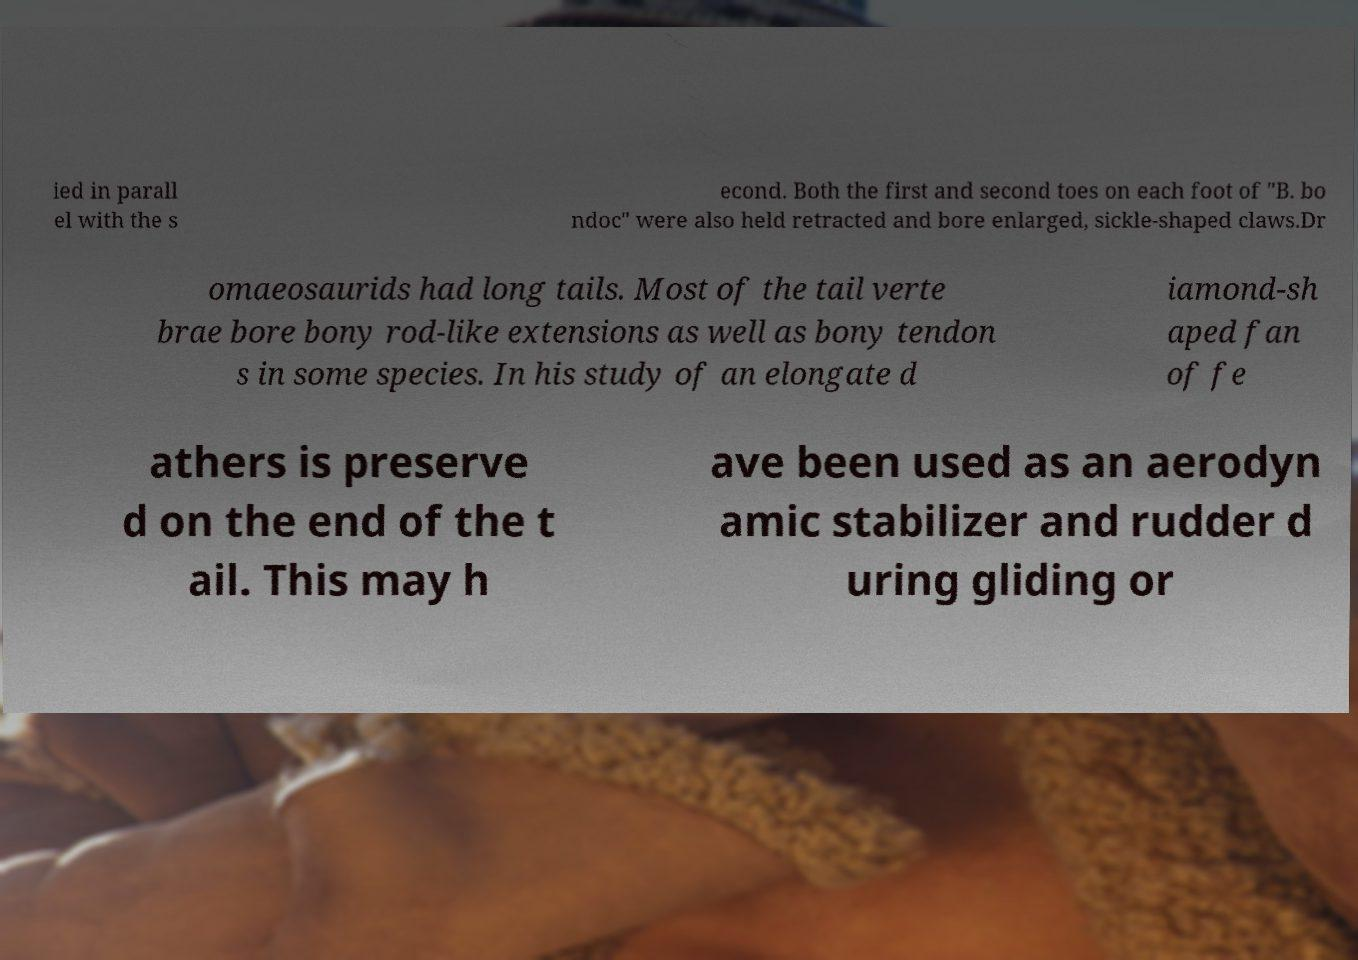Please identify and transcribe the text found in this image. ied in parall el with the s econd. Both the first and second toes on each foot of "B. bo ndoc" were also held retracted and bore enlarged, sickle-shaped claws.Dr omaeosaurids had long tails. Most of the tail verte brae bore bony rod-like extensions as well as bony tendon s in some species. In his study of an elongate d iamond-sh aped fan of fe athers is preserve d on the end of the t ail. This may h ave been used as an aerodyn amic stabilizer and rudder d uring gliding or 